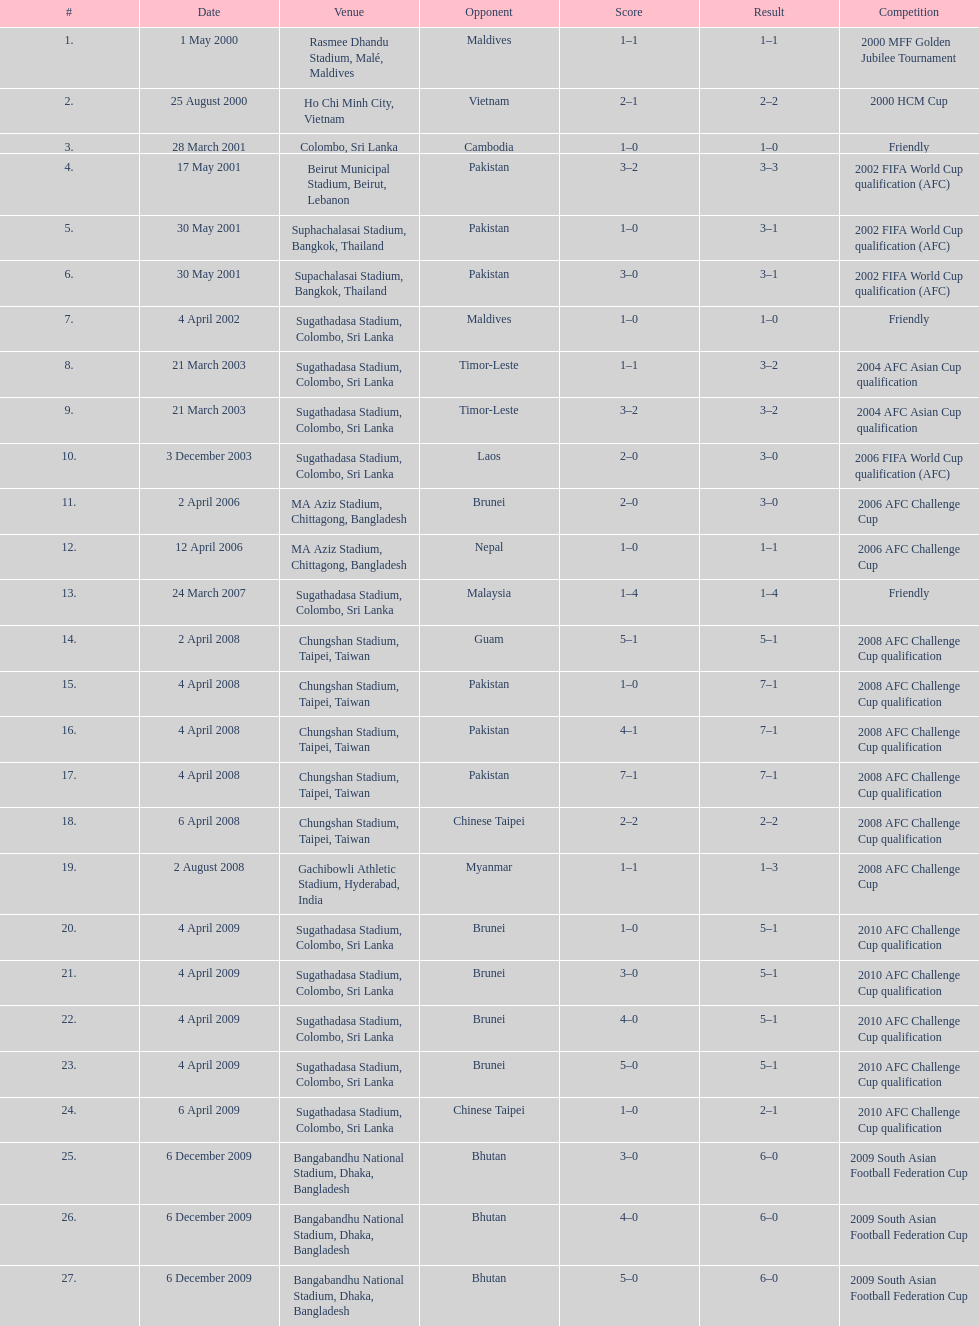What is the top listed venue in the table? Rasmee Dhandu Stadium, Malé, Maldives. 